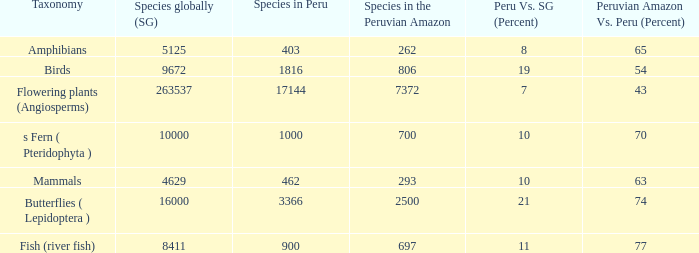Could you parse the entire table? {'header': ['Taxonomy', 'Species globally (SG)', 'Species in Peru', 'Species in the Peruvian Amazon', 'Peru Vs. SG (Percent)', 'Peruvian Amazon Vs. Peru (Percent)'], 'rows': [['Amphibians', '5125', '403', '262', '8', '65'], ['Birds', '9672', '1816', '806', '19', '54'], ['Flowering plants (Angiosperms)', '263537', '17144', '7372', '7', '43'], ['s Fern ( Pteridophyta )', '10000', '1000', '700', '10', '70'], ['Mammals', '4629', '462', '293', '10', '63'], ['Butterflies ( Lepidoptera )', '16000', '3366', '2500', '21', '74'], ['Fish (river fish)', '8411', '900', '697', '11', '77']]} What is the least number of species found in the peruvian amazon, considering there are 1000 species in peru? 700.0. 